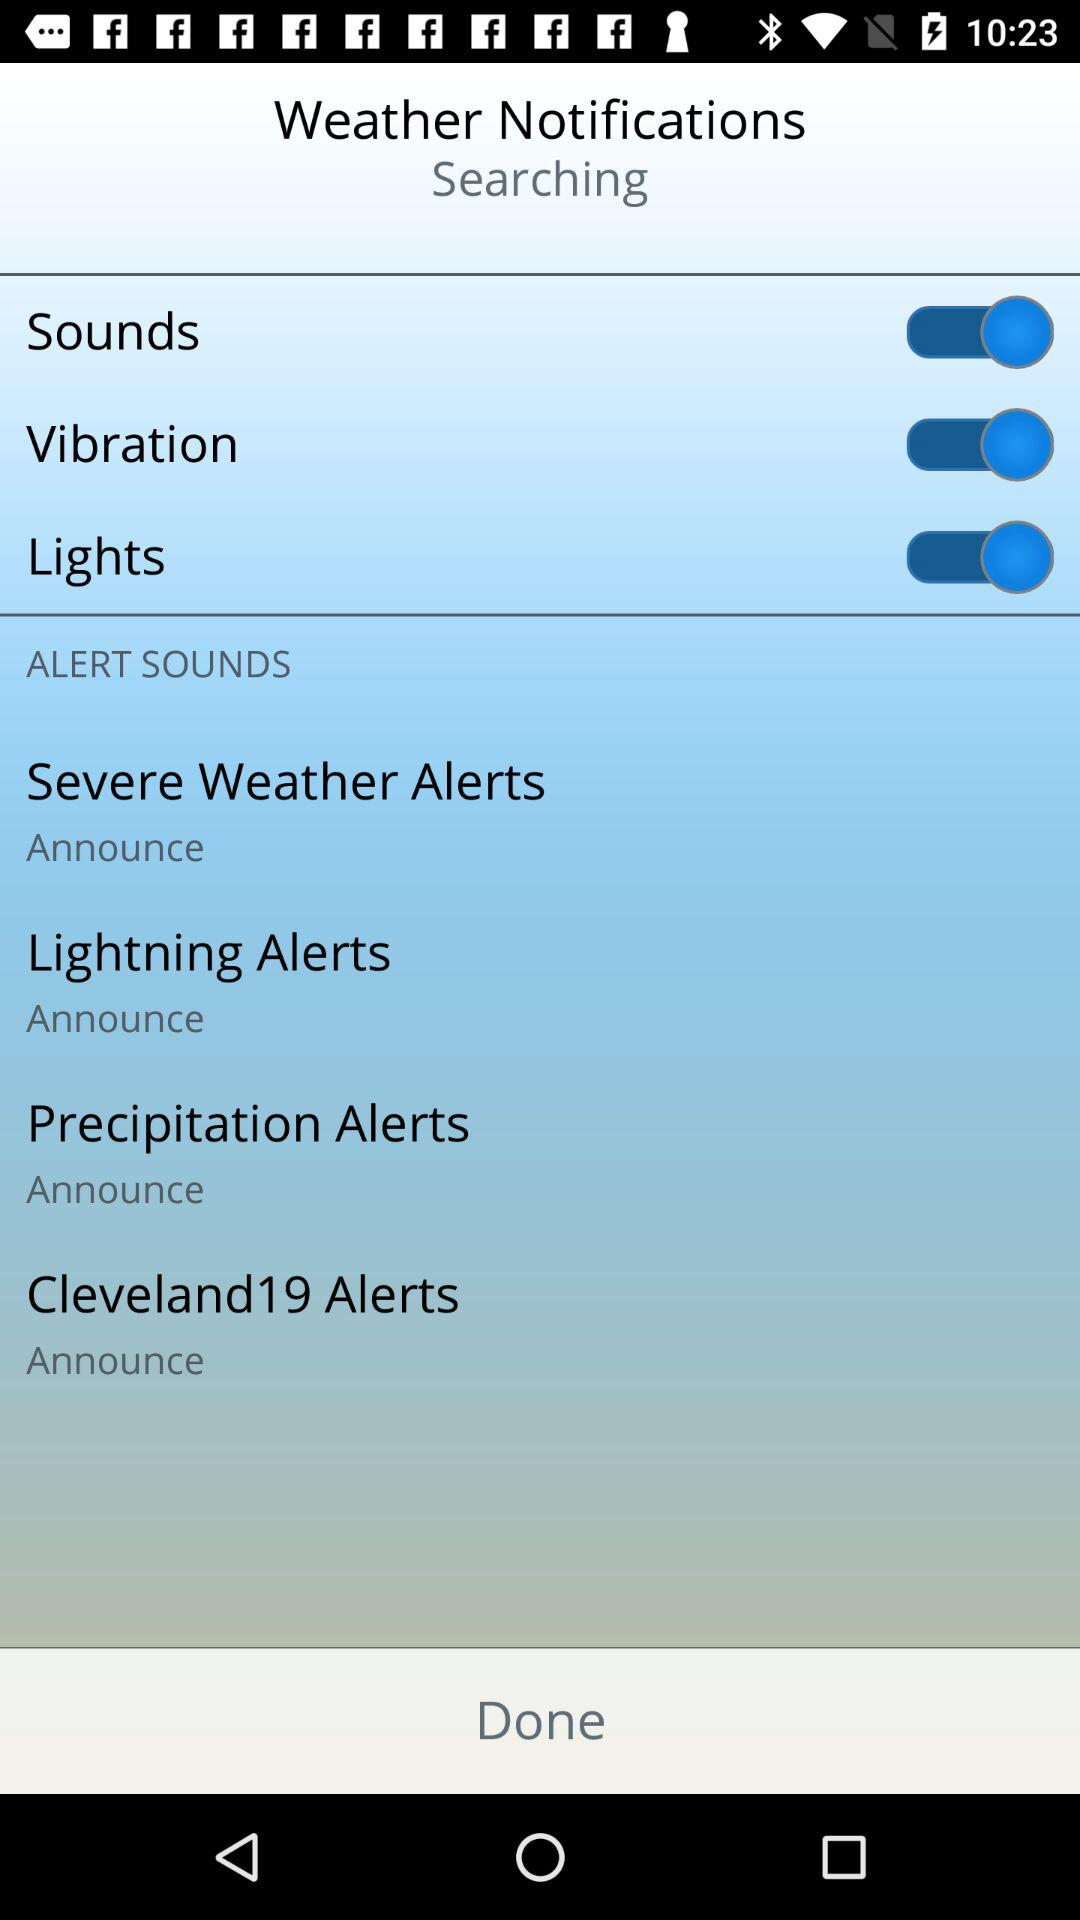How many alert sounds are there?
Answer the question using a single word or phrase. 4 